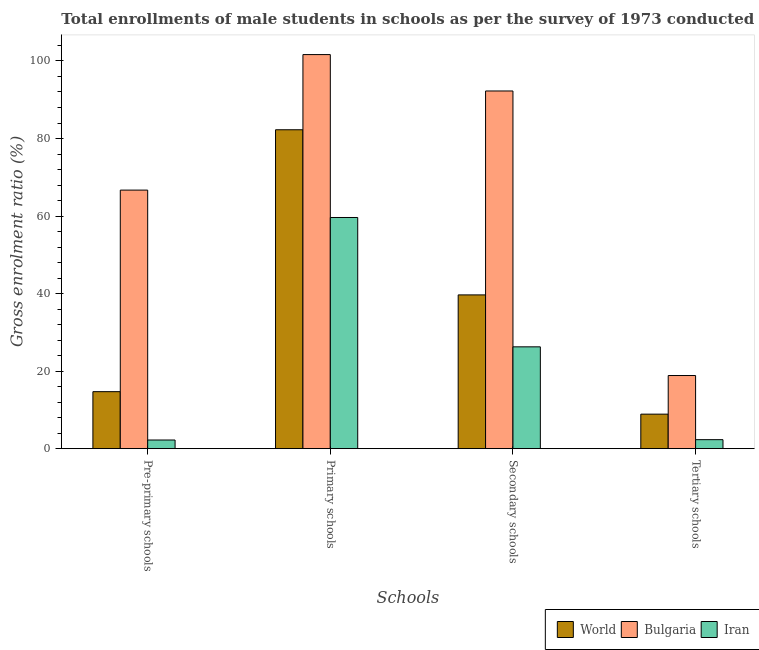How many different coloured bars are there?
Ensure brevity in your answer.  3. How many groups of bars are there?
Give a very brief answer. 4. Are the number of bars on each tick of the X-axis equal?
Provide a succinct answer. Yes. How many bars are there on the 2nd tick from the left?
Provide a short and direct response. 3. What is the label of the 2nd group of bars from the left?
Provide a short and direct response. Primary schools. What is the gross enrolment ratio(male) in primary schools in Bulgaria?
Your response must be concise. 101.65. Across all countries, what is the maximum gross enrolment ratio(male) in primary schools?
Offer a terse response. 101.65. Across all countries, what is the minimum gross enrolment ratio(male) in primary schools?
Your answer should be very brief. 59.63. In which country was the gross enrolment ratio(male) in tertiary schools maximum?
Provide a succinct answer. Bulgaria. In which country was the gross enrolment ratio(male) in primary schools minimum?
Keep it short and to the point. Iran. What is the total gross enrolment ratio(male) in secondary schools in the graph?
Give a very brief answer. 158.19. What is the difference between the gross enrolment ratio(male) in pre-primary schools in Bulgaria and that in Iran?
Your answer should be very brief. 64.46. What is the difference between the gross enrolment ratio(male) in pre-primary schools in World and the gross enrolment ratio(male) in secondary schools in Iran?
Your answer should be very brief. -11.56. What is the average gross enrolment ratio(male) in tertiary schools per country?
Make the answer very short. 10.03. What is the difference between the gross enrolment ratio(male) in primary schools and gross enrolment ratio(male) in secondary schools in World?
Offer a terse response. 42.6. In how many countries, is the gross enrolment ratio(male) in tertiary schools greater than 60 %?
Your answer should be compact. 0. What is the ratio of the gross enrolment ratio(male) in primary schools in Iran to that in World?
Your response must be concise. 0.72. Is the difference between the gross enrolment ratio(male) in primary schools in Bulgaria and World greater than the difference between the gross enrolment ratio(male) in secondary schools in Bulgaria and World?
Keep it short and to the point. No. What is the difference between the highest and the second highest gross enrolment ratio(male) in primary schools?
Offer a very short reply. 19.39. What is the difference between the highest and the lowest gross enrolment ratio(male) in pre-primary schools?
Ensure brevity in your answer.  64.46. In how many countries, is the gross enrolment ratio(male) in primary schools greater than the average gross enrolment ratio(male) in primary schools taken over all countries?
Make the answer very short. 2. Is it the case that in every country, the sum of the gross enrolment ratio(male) in primary schools and gross enrolment ratio(male) in tertiary schools is greater than the sum of gross enrolment ratio(male) in pre-primary schools and gross enrolment ratio(male) in secondary schools?
Provide a succinct answer. No. What does the 2nd bar from the left in Secondary schools represents?
Your response must be concise. Bulgaria. What does the 1st bar from the right in Tertiary schools represents?
Offer a terse response. Iran. How many countries are there in the graph?
Give a very brief answer. 3. Does the graph contain grids?
Your answer should be compact. No. How many legend labels are there?
Keep it short and to the point. 3. How are the legend labels stacked?
Offer a very short reply. Horizontal. What is the title of the graph?
Ensure brevity in your answer.  Total enrollments of male students in schools as per the survey of 1973 conducted in different countries. Does "Grenada" appear as one of the legend labels in the graph?
Ensure brevity in your answer.  No. What is the label or title of the X-axis?
Provide a succinct answer. Schools. What is the Gross enrolment ratio (%) of World in Pre-primary schools?
Ensure brevity in your answer.  14.7. What is the Gross enrolment ratio (%) of Bulgaria in Pre-primary schools?
Offer a very short reply. 66.69. What is the Gross enrolment ratio (%) of Iran in Pre-primary schools?
Provide a succinct answer. 2.24. What is the Gross enrolment ratio (%) of World in Primary schools?
Give a very brief answer. 82.26. What is the Gross enrolment ratio (%) of Bulgaria in Primary schools?
Your response must be concise. 101.65. What is the Gross enrolment ratio (%) of Iran in Primary schools?
Your answer should be compact. 59.63. What is the Gross enrolment ratio (%) in World in Secondary schools?
Offer a very short reply. 39.66. What is the Gross enrolment ratio (%) in Bulgaria in Secondary schools?
Make the answer very short. 92.26. What is the Gross enrolment ratio (%) of Iran in Secondary schools?
Your answer should be compact. 26.27. What is the Gross enrolment ratio (%) in World in Tertiary schools?
Offer a terse response. 8.91. What is the Gross enrolment ratio (%) in Bulgaria in Tertiary schools?
Keep it short and to the point. 18.87. What is the Gross enrolment ratio (%) in Iran in Tertiary schools?
Make the answer very short. 2.33. Across all Schools, what is the maximum Gross enrolment ratio (%) in World?
Provide a succinct answer. 82.26. Across all Schools, what is the maximum Gross enrolment ratio (%) of Bulgaria?
Offer a very short reply. 101.65. Across all Schools, what is the maximum Gross enrolment ratio (%) in Iran?
Your answer should be very brief. 59.63. Across all Schools, what is the minimum Gross enrolment ratio (%) in World?
Provide a succinct answer. 8.91. Across all Schools, what is the minimum Gross enrolment ratio (%) in Bulgaria?
Ensure brevity in your answer.  18.87. Across all Schools, what is the minimum Gross enrolment ratio (%) of Iran?
Your answer should be very brief. 2.24. What is the total Gross enrolment ratio (%) of World in the graph?
Keep it short and to the point. 145.53. What is the total Gross enrolment ratio (%) of Bulgaria in the graph?
Offer a terse response. 279.47. What is the total Gross enrolment ratio (%) of Iran in the graph?
Your answer should be compact. 90.46. What is the difference between the Gross enrolment ratio (%) of World in Pre-primary schools and that in Primary schools?
Offer a very short reply. -67.55. What is the difference between the Gross enrolment ratio (%) of Bulgaria in Pre-primary schools and that in Primary schools?
Your answer should be very brief. -34.95. What is the difference between the Gross enrolment ratio (%) in Iran in Pre-primary schools and that in Primary schools?
Offer a terse response. -57.39. What is the difference between the Gross enrolment ratio (%) in World in Pre-primary schools and that in Secondary schools?
Make the answer very short. -24.96. What is the difference between the Gross enrolment ratio (%) of Bulgaria in Pre-primary schools and that in Secondary schools?
Your answer should be very brief. -25.57. What is the difference between the Gross enrolment ratio (%) of Iran in Pre-primary schools and that in Secondary schools?
Keep it short and to the point. -24.03. What is the difference between the Gross enrolment ratio (%) of World in Pre-primary schools and that in Tertiary schools?
Your answer should be compact. 5.8. What is the difference between the Gross enrolment ratio (%) of Bulgaria in Pre-primary schools and that in Tertiary schools?
Your response must be concise. 47.83. What is the difference between the Gross enrolment ratio (%) of Iran in Pre-primary schools and that in Tertiary schools?
Offer a terse response. -0.09. What is the difference between the Gross enrolment ratio (%) in World in Primary schools and that in Secondary schools?
Keep it short and to the point. 42.6. What is the difference between the Gross enrolment ratio (%) in Bulgaria in Primary schools and that in Secondary schools?
Ensure brevity in your answer.  9.39. What is the difference between the Gross enrolment ratio (%) in Iran in Primary schools and that in Secondary schools?
Provide a succinct answer. 33.36. What is the difference between the Gross enrolment ratio (%) in World in Primary schools and that in Tertiary schools?
Keep it short and to the point. 73.35. What is the difference between the Gross enrolment ratio (%) of Bulgaria in Primary schools and that in Tertiary schools?
Provide a short and direct response. 82.78. What is the difference between the Gross enrolment ratio (%) of Iran in Primary schools and that in Tertiary schools?
Give a very brief answer. 57.31. What is the difference between the Gross enrolment ratio (%) in World in Secondary schools and that in Tertiary schools?
Keep it short and to the point. 30.76. What is the difference between the Gross enrolment ratio (%) of Bulgaria in Secondary schools and that in Tertiary schools?
Your answer should be compact. 73.39. What is the difference between the Gross enrolment ratio (%) in Iran in Secondary schools and that in Tertiary schools?
Make the answer very short. 23.94. What is the difference between the Gross enrolment ratio (%) of World in Pre-primary schools and the Gross enrolment ratio (%) of Bulgaria in Primary schools?
Your answer should be compact. -86.95. What is the difference between the Gross enrolment ratio (%) of World in Pre-primary schools and the Gross enrolment ratio (%) of Iran in Primary schools?
Provide a short and direct response. -44.93. What is the difference between the Gross enrolment ratio (%) of Bulgaria in Pre-primary schools and the Gross enrolment ratio (%) of Iran in Primary schools?
Keep it short and to the point. 7.06. What is the difference between the Gross enrolment ratio (%) in World in Pre-primary schools and the Gross enrolment ratio (%) in Bulgaria in Secondary schools?
Provide a short and direct response. -77.56. What is the difference between the Gross enrolment ratio (%) in World in Pre-primary schools and the Gross enrolment ratio (%) in Iran in Secondary schools?
Offer a terse response. -11.56. What is the difference between the Gross enrolment ratio (%) of Bulgaria in Pre-primary schools and the Gross enrolment ratio (%) of Iran in Secondary schools?
Provide a succinct answer. 40.43. What is the difference between the Gross enrolment ratio (%) in World in Pre-primary schools and the Gross enrolment ratio (%) in Bulgaria in Tertiary schools?
Ensure brevity in your answer.  -4.17. What is the difference between the Gross enrolment ratio (%) in World in Pre-primary schools and the Gross enrolment ratio (%) in Iran in Tertiary schools?
Your answer should be compact. 12.38. What is the difference between the Gross enrolment ratio (%) in Bulgaria in Pre-primary schools and the Gross enrolment ratio (%) in Iran in Tertiary schools?
Offer a terse response. 64.37. What is the difference between the Gross enrolment ratio (%) in World in Primary schools and the Gross enrolment ratio (%) in Bulgaria in Secondary schools?
Your response must be concise. -10. What is the difference between the Gross enrolment ratio (%) of World in Primary schools and the Gross enrolment ratio (%) of Iran in Secondary schools?
Provide a short and direct response. 55.99. What is the difference between the Gross enrolment ratio (%) in Bulgaria in Primary schools and the Gross enrolment ratio (%) in Iran in Secondary schools?
Ensure brevity in your answer.  75.38. What is the difference between the Gross enrolment ratio (%) of World in Primary schools and the Gross enrolment ratio (%) of Bulgaria in Tertiary schools?
Ensure brevity in your answer.  63.39. What is the difference between the Gross enrolment ratio (%) of World in Primary schools and the Gross enrolment ratio (%) of Iran in Tertiary schools?
Make the answer very short. 79.93. What is the difference between the Gross enrolment ratio (%) of Bulgaria in Primary schools and the Gross enrolment ratio (%) of Iran in Tertiary schools?
Your answer should be compact. 99.32. What is the difference between the Gross enrolment ratio (%) in World in Secondary schools and the Gross enrolment ratio (%) in Bulgaria in Tertiary schools?
Provide a short and direct response. 20.79. What is the difference between the Gross enrolment ratio (%) of World in Secondary schools and the Gross enrolment ratio (%) of Iran in Tertiary schools?
Your response must be concise. 37.34. What is the difference between the Gross enrolment ratio (%) of Bulgaria in Secondary schools and the Gross enrolment ratio (%) of Iran in Tertiary schools?
Ensure brevity in your answer.  89.93. What is the average Gross enrolment ratio (%) of World per Schools?
Provide a short and direct response. 36.38. What is the average Gross enrolment ratio (%) of Bulgaria per Schools?
Your answer should be compact. 69.87. What is the average Gross enrolment ratio (%) of Iran per Schools?
Keep it short and to the point. 22.62. What is the difference between the Gross enrolment ratio (%) of World and Gross enrolment ratio (%) of Bulgaria in Pre-primary schools?
Offer a very short reply. -51.99. What is the difference between the Gross enrolment ratio (%) in World and Gross enrolment ratio (%) in Iran in Pre-primary schools?
Offer a terse response. 12.47. What is the difference between the Gross enrolment ratio (%) of Bulgaria and Gross enrolment ratio (%) of Iran in Pre-primary schools?
Your response must be concise. 64.46. What is the difference between the Gross enrolment ratio (%) of World and Gross enrolment ratio (%) of Bulgaria in Primary schools?
Offer a very short reply. -19.39. What is the difference between the Gross enrolment ratio (%) in World and Gross enrolment ratio (%) in Iran in Primary schools?
Your answer should be compact. 22.63. What is the difference between the Gross enrolment ratio (%) in Bulgaria and Gross enrolment ratio (%) in Iran in Primary schools?
Give a very brief answer. 42.02. What is the difference between the Gross enrolment ratio (%) in World and Gross enrolment ratio (%) in Bulgaria in Secondary schools?
Keep it short and to the point. -52.6. What is the difference between the Gross enrolment ratio (%) in World and Gross enrolment ratio (%) in Iran in Secondary schools?
Offer a very short reply. 13.39. What is the difference between the Gross enrolment ratio (%) in Bulgaria and Gross enrolment ratio (%) in Iran in Secondary schools?
Make the answer very short. 65.99. What is the difference between the Gross enrolment ratio (%) in World and Gross enrolment ratio (%) in Bulgaria in Tertiary schools?
Ensure brevity in your answer.  -9.96. What is the difference between the Gross enrolment ratio (%) in World and Gross enrolment ratio (%) in Iran in Tertiary schools?
Keep it short and to the point. 6.58. What is the difference between the Gross enrolment ratio (%) of Bulgaria and Gross enrolment ratio (%) of Iran in Tertiary schools?
Your answer should be very brief. 16.54. What is the ratio of the Gross enrolment ratio (%) of World in Pre-primary schools to that in Primary schools?
Ensure brevity in your answer.  0.18. What is the ratio of the Gross enrolment ratio (%) in Bulgaria in Pre-primary schools to that in Primary schools?
Your response must be concise. 0.66. What is the ratio of the Gross enrolment ratio (%) in Iran in Pre-primary schools to that in Primary schools?
Offer a terse response. 0.04. What is the ratio of the Gross enrolment ratio (%) in World in Pre-primary schools to that in Secondary schools?
Your answer should be very brief. 0.37. What is the ratio of the Gross enrolment ratio (%) in Bulgaria in Pre-primary schools to that in Secondary schools?
Give a very brief answer. 0.72. What is the ratio of the Gross enrolment ratio (%) in Iran in Pre-primary schools to that in Secondary schools?
Provide a succinct answer. 0.09. What is the ratio of the Gross enrolment ratio (%) in World in Pre-primary schools to that in Tertiary schools?
Offer a very short reply. 1.65. What is the ratio of the Gross enrolment ratio (%) of Bulgaria in Pre-primary schools to that in Tertiary schools?
Provide a succinct answer. 3.53. What is the ratio of the Gross enrolment ratio (%) in Iran in Pre-primary schools to that in Tertiary schools?
Your answer should be compact. 0.96. What is the ratio of the Gross enrolment ratio (%) in World in Primary schools to that in Secondary schools?
Your response must be concise. 2.07. What is the ratio of the Gross enrolment ratio (%) in Bulgaria in Primary schools to that in Secondary schools?
Your answer should be very brief. 1.1. What is the ratio of the Gross enrolment ratio (%) of Iran in Primary schools to that in Secondary schools?
Offer a terse response. 2.27. What is the ratio of the Gross enrolment ratio (%) of World in Primary schools to that in Tertiary schools?
Keep it short and to the point. 9.23. What is the ratio of the Gross enrolment ratio (%) of Bulgaria in Primary schools to that in Tertiary schools?
Give a very brief answer. 5.39. What is the ratio of the Gross enrolment ratio (%) of Iran in Primary schools to that in Tertiary schools?
Provide a short and direct response. 25.64. What is the ratio of the Gross enrolment ratio (%) of World in Secondary schools to that in Tertiary schools?
Keep it short and to the point. 4.45. What is the ratio of the Gross enrolment ratio (%) of Bulgaria in Secondary schools to that in Tertiary schools?
Ensure brevity in your answer.  4.89. What is the ratio of the Gross enrolment ratio (%) of Iran in Secondary schools to that in Tertiary schools?
Ensure brevity in your answer.  11.29. What is the difference between the highest and the second highest Gross enrolment ratio (%) of World?
Your response must be concise. 42.6. What is the difference between the highest and the second highest Gross enrolment ratio (%) in Bulgaria?
Keep it short and to the point. 9.39. What is the difference between the highest and the second highest Gross enrolment ratio (%) in Iran?
Give a very brief answer. 33.36. What is the difference between the highest and the lowest Gross enrolment ratio (%) of World?
Your response must be concise. 73.35. What is the difference between the highest and the lowest Gross enrolment ratio (%) of Bulgaria?
Your response must be concise. 82.78. What is the difference between the highest and the lowest Gross enrolment ratio (%) in Iran?
Ensure brevity in your answer.  57.39. 